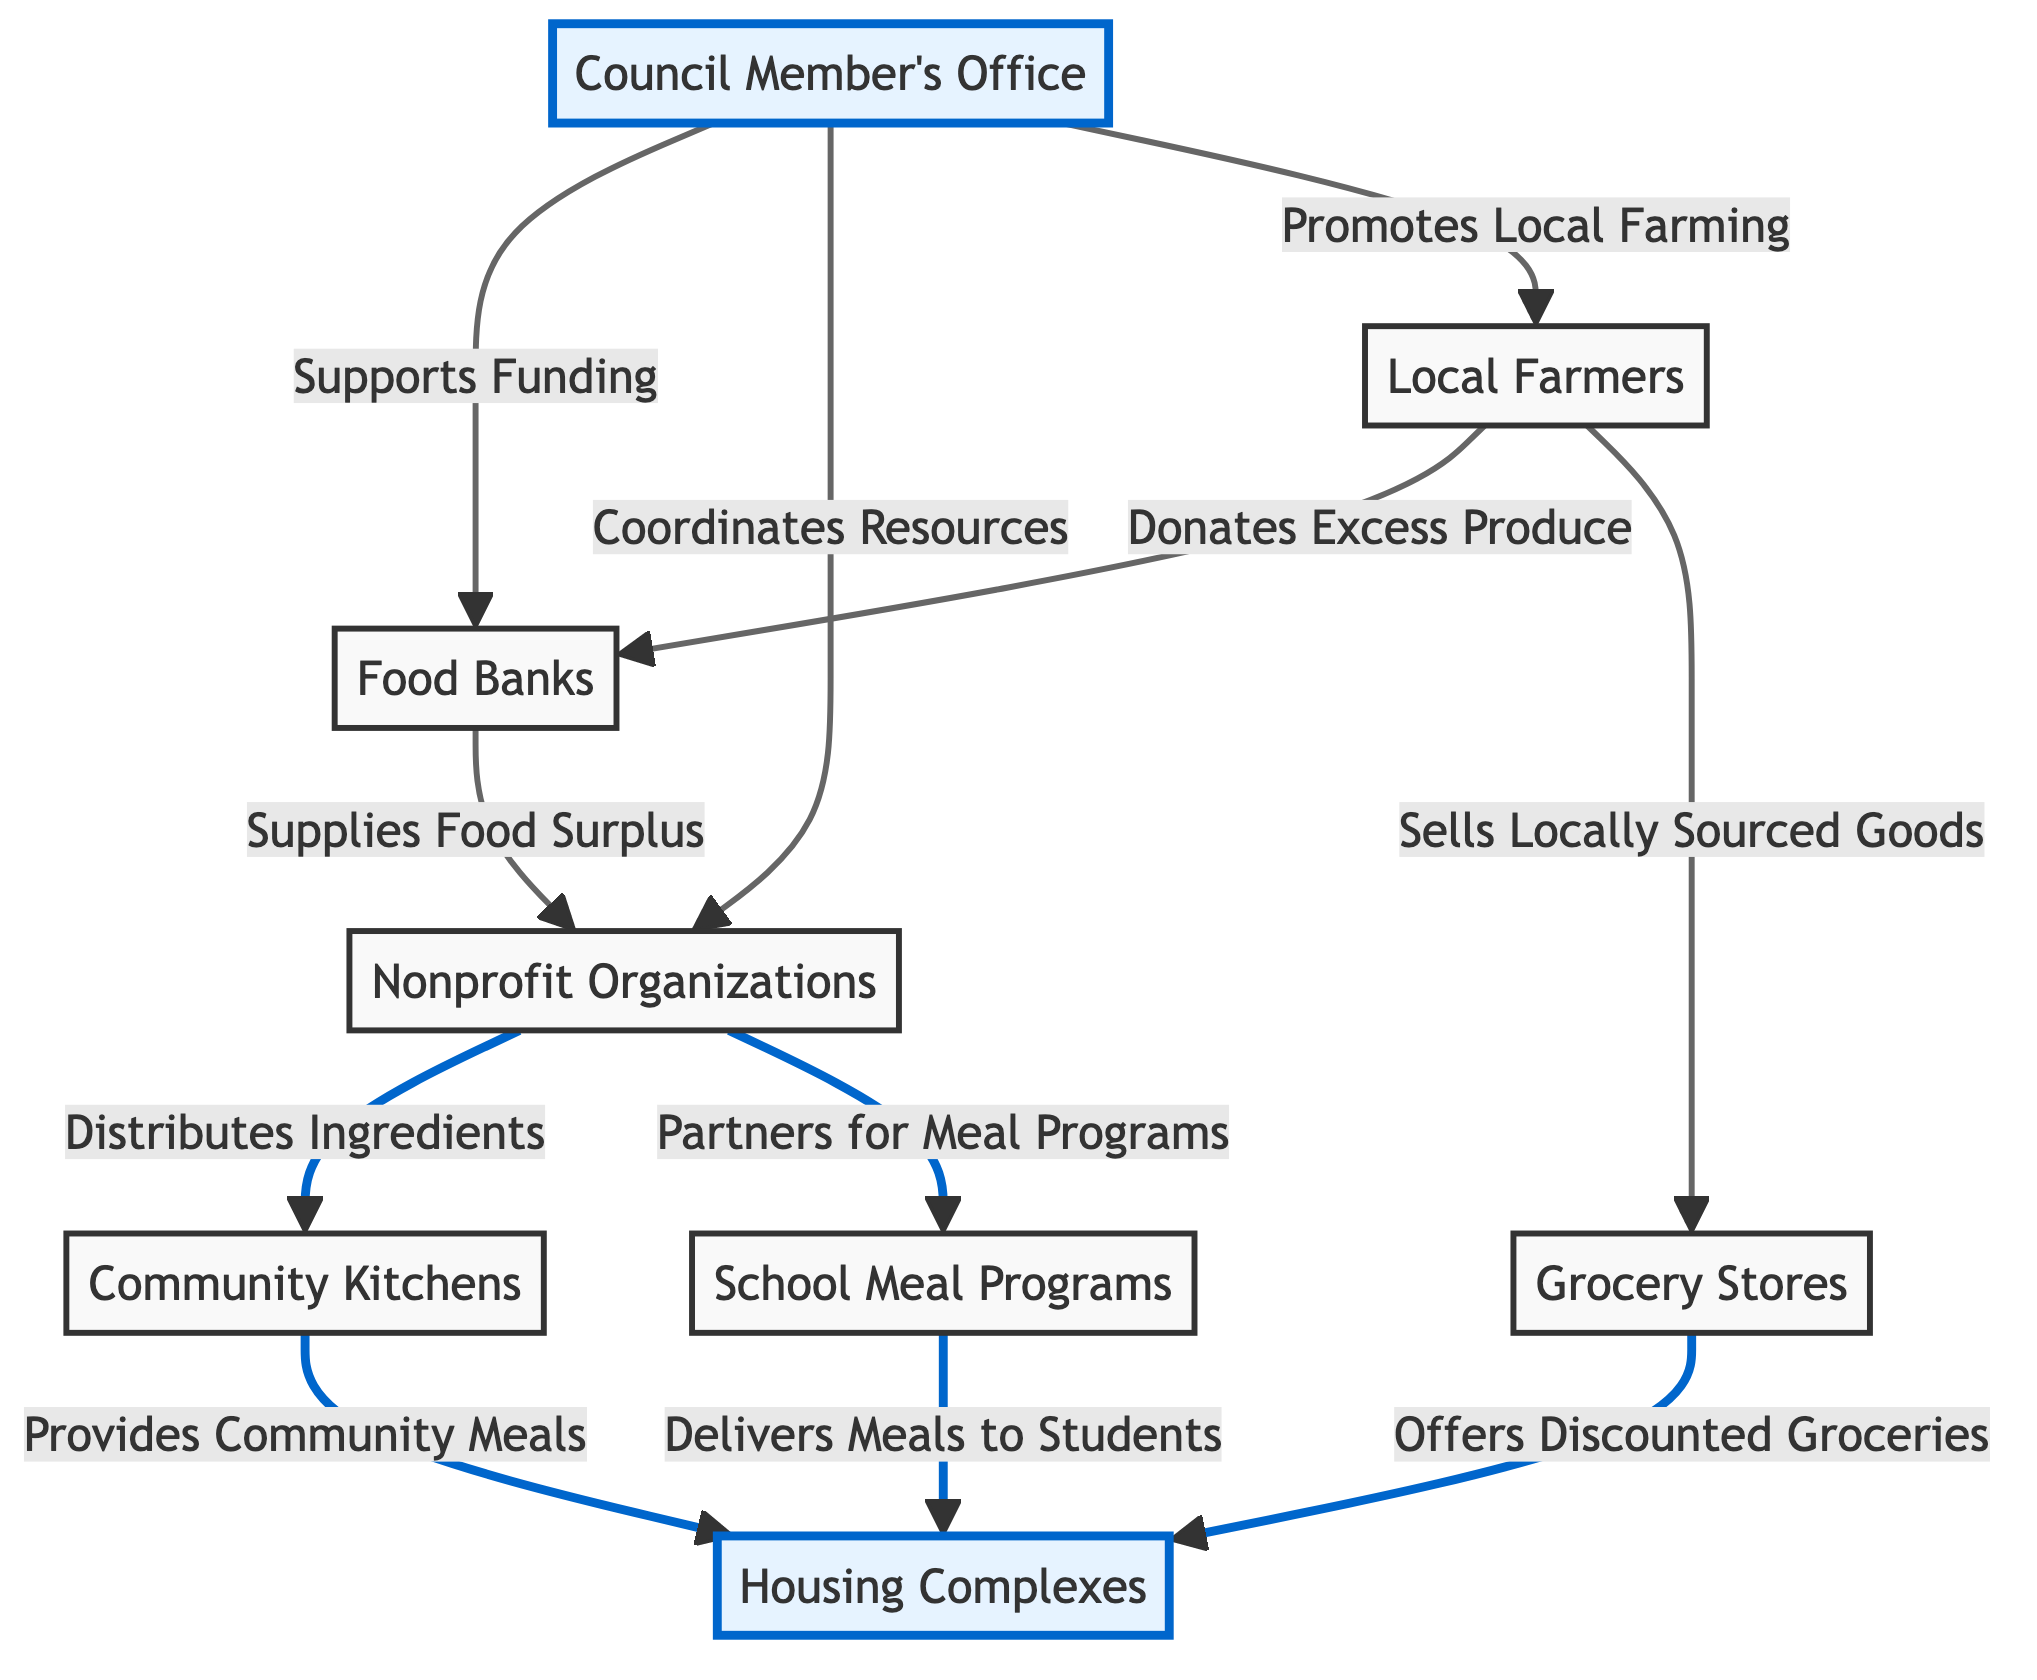What nodes donate food to Food Banks? The diagram indicates that Local Farmers donate excess produce to Food Banks. This can be seen in the flow from Local Farmers to Food Banks labeled "Donates Excess Produce."
Answer: Local Farmers How many nodes are there in the diagram? The diagram has eight nodes, which can be individually counted: Local Farmers, Food Banks, Nonprofit Organizations, Community Kitchens, Grocery Stores, School Meal Programs, Housing Complexes, and Council Member's Office.
Answer: Eight What do Nonprofit Organizations distribute? According to the diagram, Nonprofit Organizations distribute ingredients to Community Kitchens. This is shown by the directed edge labeled "Distributes Ingredients" from Nonprofit Organizations to Community Kitchens.
Answer: Ingredients Which two entities do Community Kitchens provide meals to? The diagram shows that Community Kitchens provide community meals to Housing Complexes and work with School Meal Programs to deliver meals. Therefore, the two entities are Housing Complexes and School Meal Programs.
Answer: Housing Complexes, School Meal Programs How does the Council Member's Office support Food Banks? The diagram indicates the Council Member's Office supports Food Banks by providing funding. This is reflected in the flow labeled "Supports Funding" from the Council Member's Office to Food Banks.
Answer: Funding What is the connection between Food Banks and Nonprofit Organizations? The connection between Food Banks and Nonprofit Organizations is through the supply of food surplus. The diagram illustrates this with the label "Supplies Food Surplus" going from Food Banks to Nonprofit Organizations, creating a clear relationship between the two.
Answer: Supplies Food Surplus How do Local Farmers contribute to Grocery Stores? The diagram outlines that Local Farmers sell locally sourced goods to Grocery Stores. This relationship is depicted by the directional flow labeled "Sells Locally Sourced Goods" connecting Local Farmers to Grocery Stores.
Answer: Sells Locally Sourced Goods What role does the Council Member's Office play in promoting Local Farming? The diagram indicates that the Council Member's Office promotes local farming by coordinating resources. This is represented by the flow labeled "Promotes Local Farming" going from the Council Member's Office to Local Farmers, emphasizing their supportive role.
Answer: Promotes Local Farming 